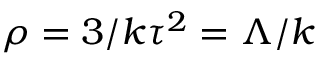Convert formula to latex. <formula><loc_0><loc_0><loc_500><loc_500>\rho = 3 / k \tau ^ { 2 } = \Lambda / k</formula> 